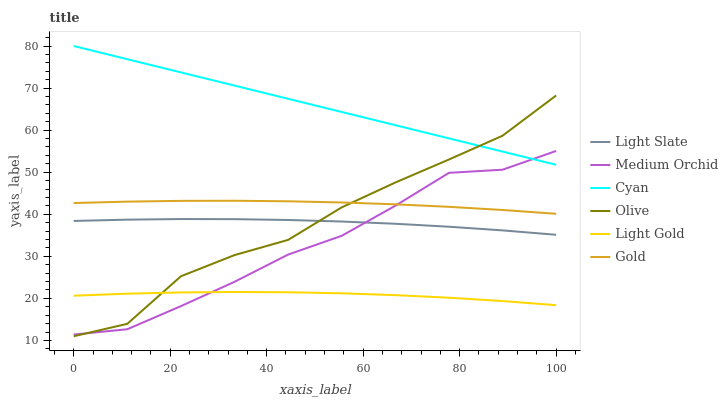Does Light Slate have the minimum area under the curve?
Answer yes or no. No. Does Light Slate have the maximum area under the curve?
Answer yes or no. No. Is Light Slate the smoothest?
Answer yes or no. No. Is Light Slate the roughest?
Answer yes or no. No. Does Light Slate have the lowest value?
Answer yes or no. No. Does Light Slate have the highest value?
Answer yes or no. No. Is Light Gold less than Cyan?
Answer yes or no. Yes. Is Gold greater than Light Gold?
Answer yes or no. Yes. Does Light Gold intersect Cyan?
Answer yes or no. No. 